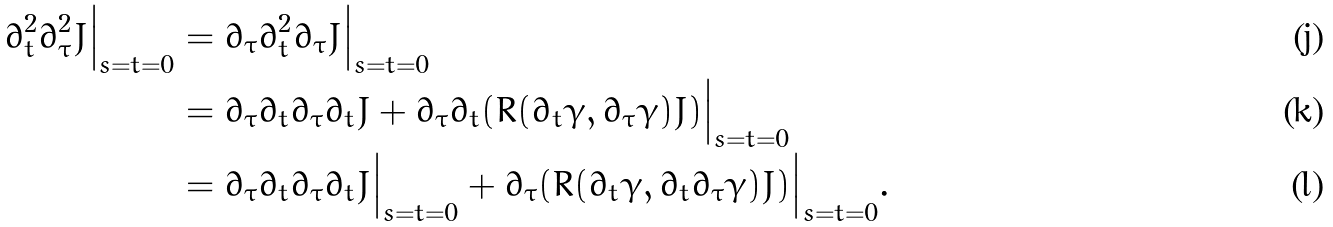Convert formula to latex. <formula><loc_0><loc_0><loc_500><loc_500>\partial _ { t } ^ { 2 } \partial _ { \tau } ^ { 2 } J \Big | _ { s = t = 0 } & = \partial _ { \tau } \partial _ { t } ^ { 2 } \partial _ { \tau } J \Big | _ { s = t = 0 } \\ & = \partial _ { \tau } \partial _ { t } \partial _ { \tau } \partial _ { t } J + \partial _ { \tau } \partial _ { t } ( R ( \partial _ { t } \gamma , \partial _ { \tau } \gamma ) J ) \Big | _ { s = t = 0 } \\ & = \partial _ { \tau } \partial _ { t } \partial _ { \tau } \partial _ { t } J \Big | _ { s = t = 0 } + \partial _ { \tau } ( R ( \partial _ { t } \gamma , \partial _ { t } \partial _ { \tau } \gamma ) J ) \Big | _ { s = t = 0 } .</formula> 